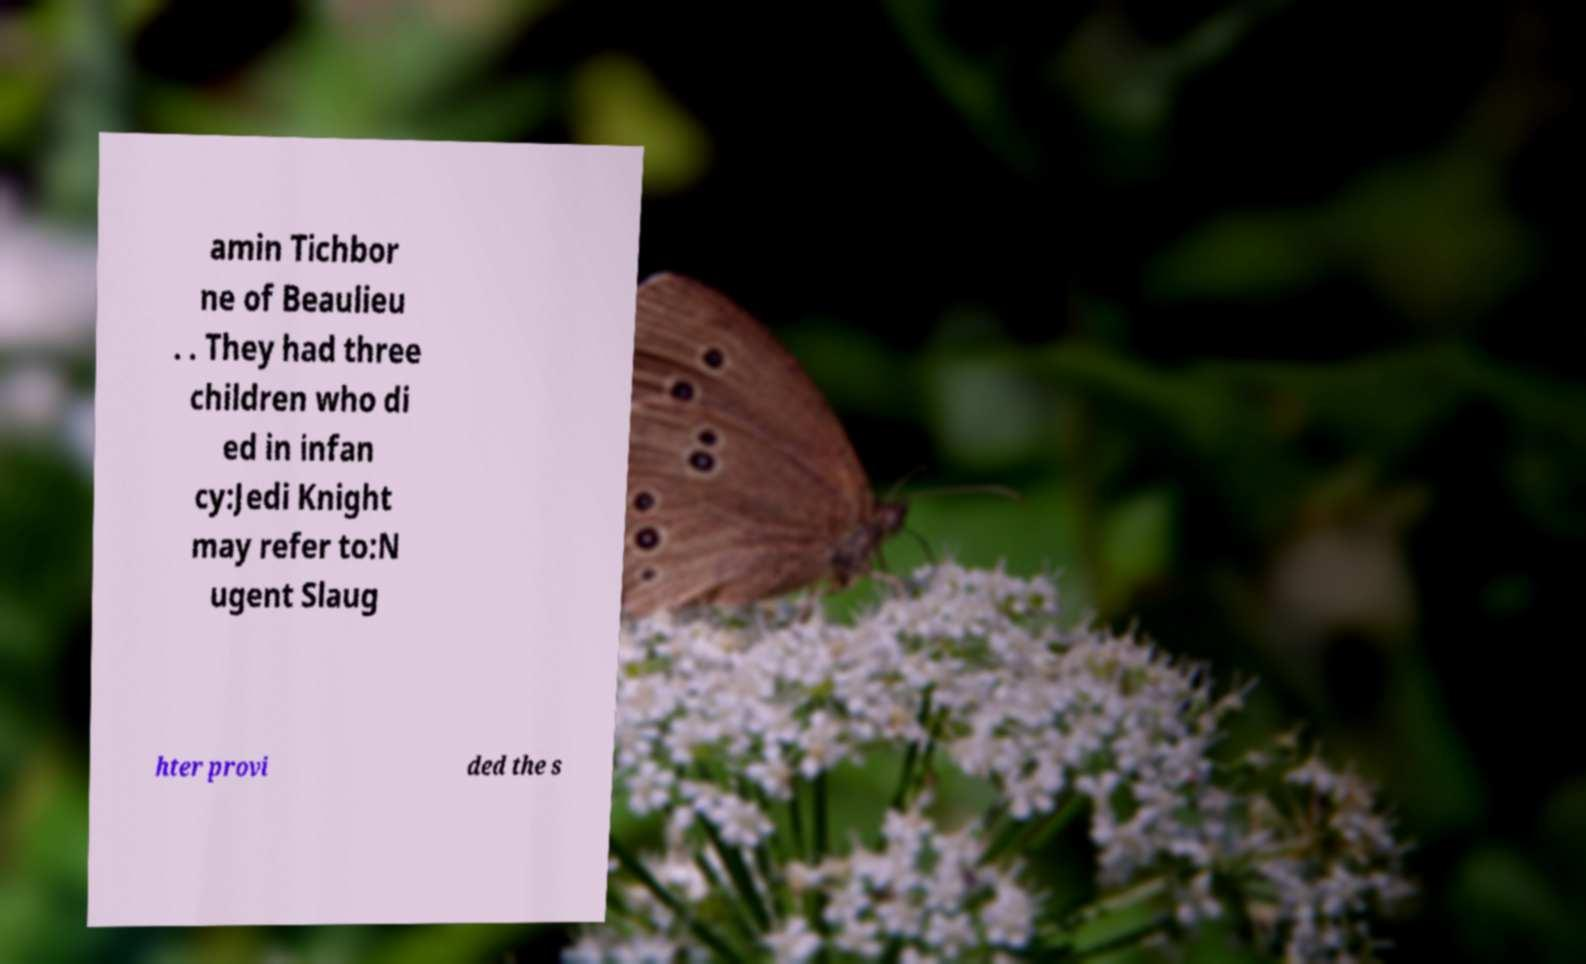For documentation purposes, I need the text within this image transcribed. Could you provide that? amin Tichbor ne of Beaulieu . . They had three children who di ed in infan cy:Jedi Knight may refer to:N ugent Slaug hter provi ded the s 